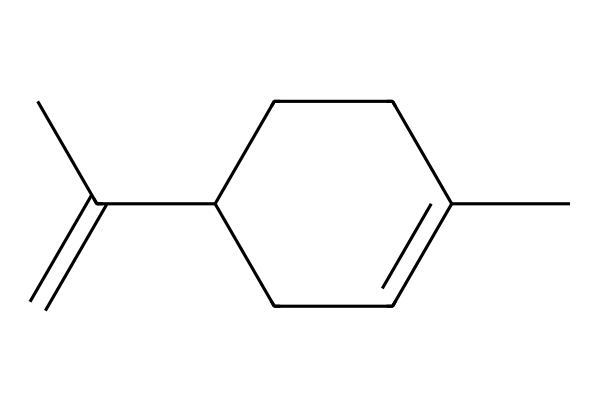What is the molecular formula of limonene? To find the molecular formula, we identify the number of each type of atom from the given SMILES: C represents carbon and H represents hydrogen. The SMILES indicates there are 10 carbon atoms and 16 hydrogen atoms. Thus, the molecular formula is C10H16.
Answer: C10H16 How many double bonds are present in limonene? The structure from the SMILES indicates the locations of double bonds. In limonene, there is one double bond between the carbon atoms. This can be recognized from the C(=C) notation in the SMILES.
Answer: 1 What is the main functional group present in limonene? The structure of limonene does not exhibit typical functional groups like alcohols or carboxylic acids. It is primarily characterized as an alkene due to the presence of a double bond, suggesting it is a hydrocarbon.
Answer: alkene How many rings are there in the structure of limonene? Analyzing the SMILES, we see 'C1' at the beginning, indicating the start of a cyclic structure. The 'CC1' notation shows that there is one ring formed in the structure.
Answer: 1 Is limonene a saturated or unsaturated compound? Since limonene contains a double bond, it cannot be fully saturated with hydrogen. Saturated compounds have only single bonds, while unsaturated ones, like limonene, contain one or more double bonds.
Answer: unsaturated What type of terpene is limonene classified as? Limonene is classified as a monoterpene because it consists of two isoprene units (which have 10 carbon atoms). This classification is based on its structure containing two linked isoprene units.
Answer: monoterpene 